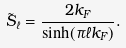<formula> <loc_0><loc_0><loc_500><loc_500>\tilde { S } _ { \ell } = \frac { 2 k _ { F } } { \sinh ( \pi \ell k _ { F } ) } .</formula> 